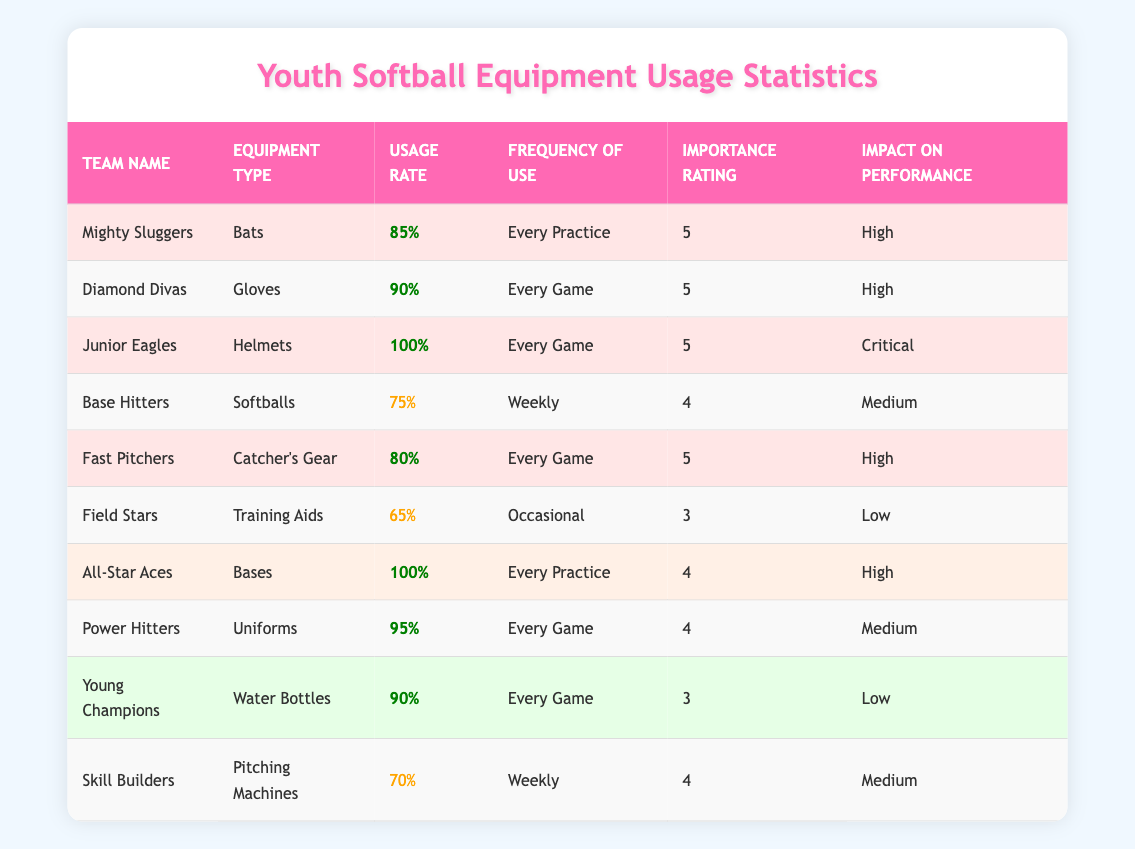What team uses helmets with the highest usage rate? The highest usage rate for helmets is 100%, which is used by the Junior Eagles. This can be easily identified by looking for the equipment type "Helmets" in the table and checking the usage rate associated with it.
Answer: Junior Eagles Which equipment type has the lowest usage rate among the teams? The lowest usage rate is 65%, corresponding to the Training Aids used by the Field Stars. By examining the usage rates in the table, we can find that this is the smallest value.
Answer: Training Aids How many teams have a frequency of use labeled as "Every Game"? To find the teams that use equipment "Every Game," we check the frequency of use column and count the occurrences. In total, there are five teams that fit this criterion: Diamond Divas, Junior Eagles, Fast Pitchers, Power Hitters, and Young Champions.
Answer: 5 What is the average importance rating of the teams using uniforms? The only team using uniforms is the Power Hitters with an importance rating of 4. Since there is only one team, the average is simply that team's importance rating itself.
Answer: 4 Is it true that all teams with a usage rate above 80% have a high impact on performance? To answer this, we examine the teams with usage rates over 80%. The teams are Mighty Sluggers (85%, High), Diamond Divas (90%, High), Junior Eagles (100%, Critical), Fast Pitchers (80%, High), All-Star Aces (100%, High), and Power Hitters (95%, Medium). While all but one have high impact ratings, one has a medium impact rating. Thus, the statement is false.
Answer: No Among the teams that use equipment weekly, what is the average usage rate? The teams that use equipment weekly are the Base Hitters (75%) and Skill Builders (70%). To calculate the average, we sum these two rates: 75 + 70 = 145, and then divide by the number of teams, which is 2: 145 / 2 = 72.5.
Answer: 72.5 Which team has the highest frequency of use for training aids, and what is its importance rating? The Field Stars use Training Aids with a frequency of "Occasional," and their importance rating is 3. By finding "Training Aids" in the table and checking the corresponding row, we can determine this information.
Answer: Field Stars, 3 How many teams have equipment rated at an importance level of 3? By reviewing the table, the teams with an importance rating of 3 are Field Stars and Young Champions. The total count is two teams, which can be easily found by scanning through the importance ratings.
Answer: 2 